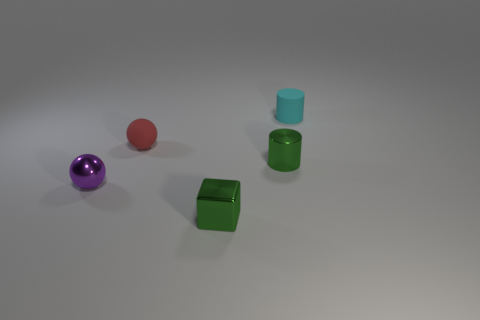Are there any other blue blocks that have the same size as the block?
Make the answer very short. No. What is the material of the cube that is the same size as the metal sphere?
Make the answer very short. Metal. What shape is the small object behind the rubber ball?
Keep it short and to the point. Cylinder. Do the tiny cylinder that is behind the green cylinder and the small cylinder that is in front of the tiny cyan cylinder have the same material?
Keep it short and to the point. No. What number of green shiny objects are the same shape as the small cyan matte object?
Offer a very short reply. 1. There is a block that is the same color as the metal cylinder; what material is it?
Provide a short and direct response. Metal. What number of things are tiny brown rubber cylinders or small things that are in front of the cyan rubber cylinder?
Your answer should be very brief. 4. What material is the purple ball?
Make the answer very short. Metal. What is the material of the red object that is the same shape as the purple metal object?
Provide a short and direct response. Rubber. The thing that is to the left of the tiny red matte object behind the tiny purple shiny object is what color?
Give a very brief answer. Purple. 